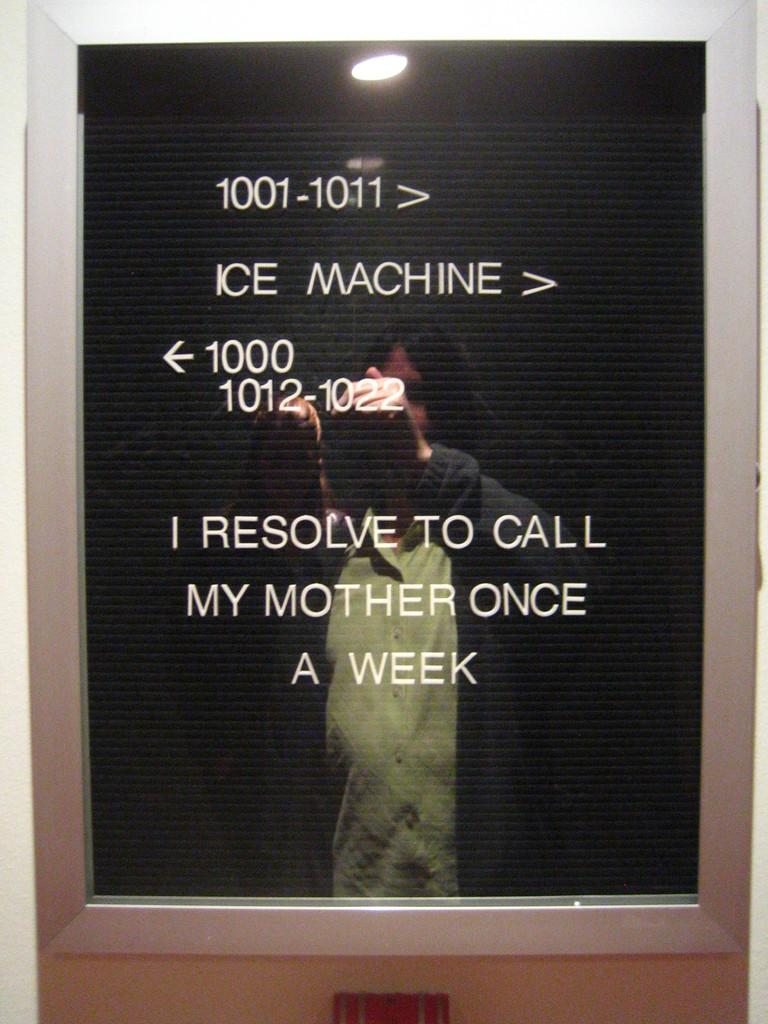<image>
Summarize the visual content of the image. a sign that says mother on it in white 